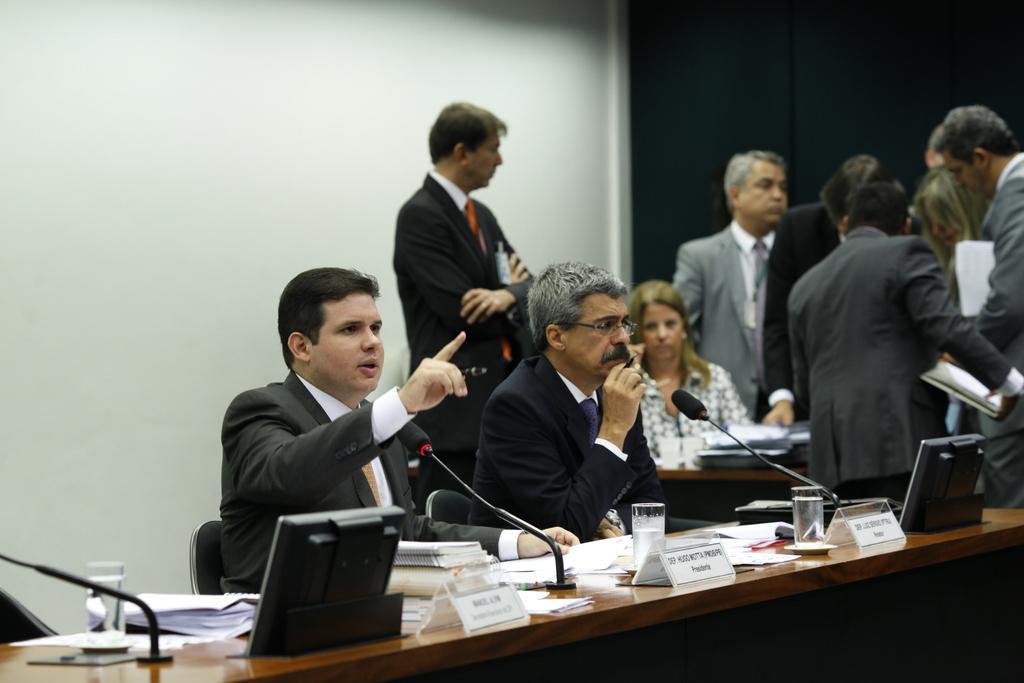Can you describe this image briefly? In this image there are two person's seated in chairs speaking on the mic, in front of the two person's there is a table, on the table there are few papers, glass of water, name plates and mics, behind them there are few other people standing and there is a girl seated in a chair. 